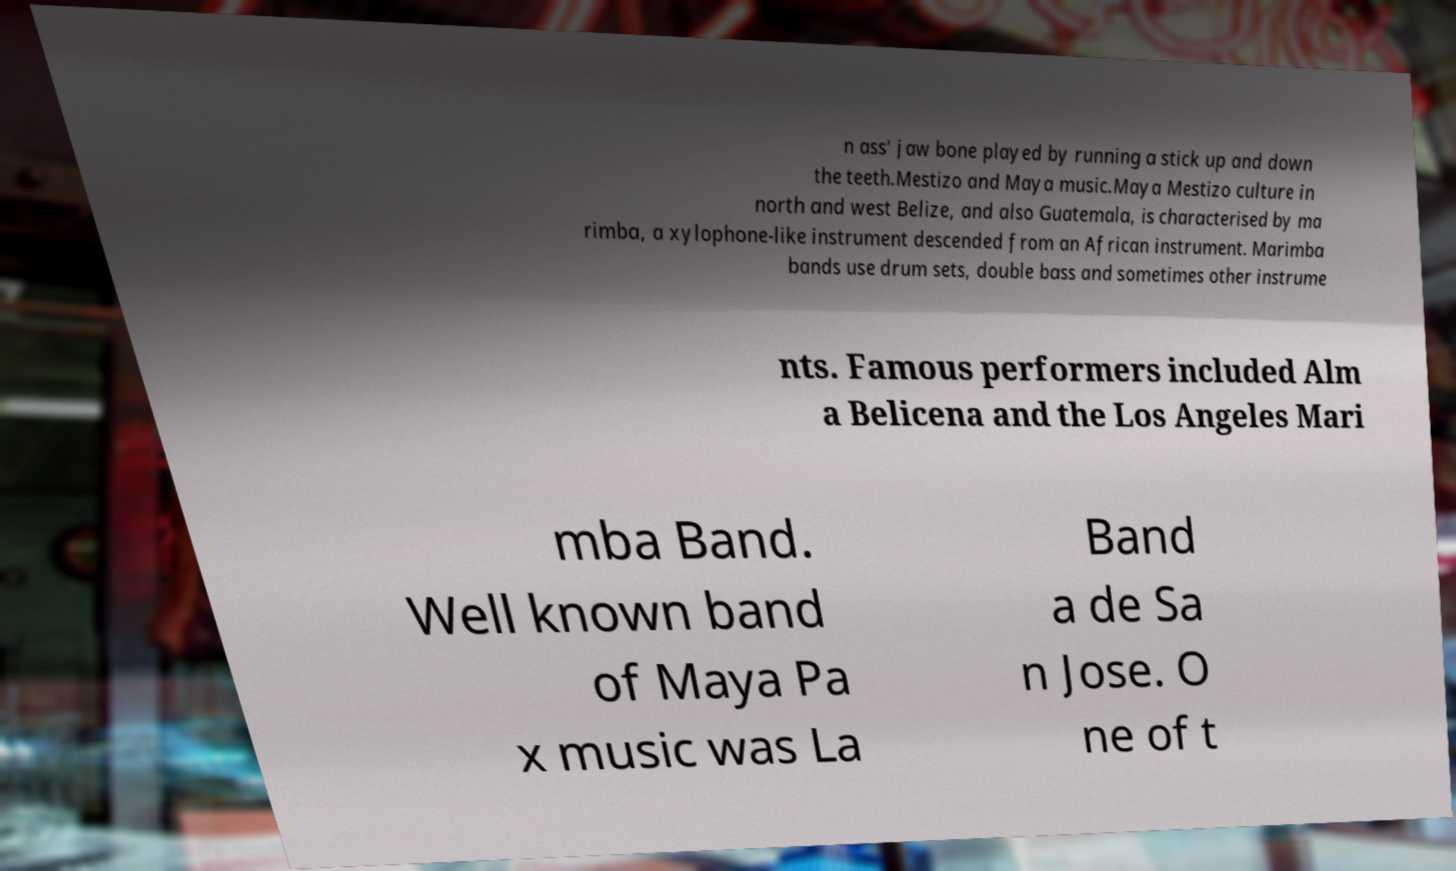Please identify and transcribe the text found in this image. n ass' jaw bone played by running a stick up and down the teeth.Mestizo and Maya music.Maya Mestizo culture in north and west Belize, and also Guatemala, is characterised by ma rimba, a xylophone-like instrument descended from an African instrument. Marimba bands use drum sets, double bass and sometimes other instrume nts. Famous performers included Alm a Belicena and the Los Angeles Mari mba Band. Well known band of Maya Pa x music was La Band a de Sa n Jose. O ne of t 